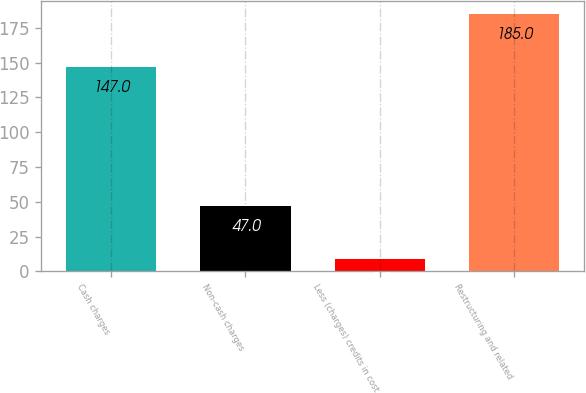Convert chart. <chart><loc_0><loc_0><loc_500><loc_500><bar_chart><fcel>Cash charges<fcel>Non-cash charges<fcel>Less (charges) credits in cost<fcel>Restructuring and related<nl><fcel>147<fcel>47<fcel>9<fcel>185<nl></chart> 